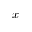<formula> <loc_0><loc_0><loc_500><loc_500>x</formula> 